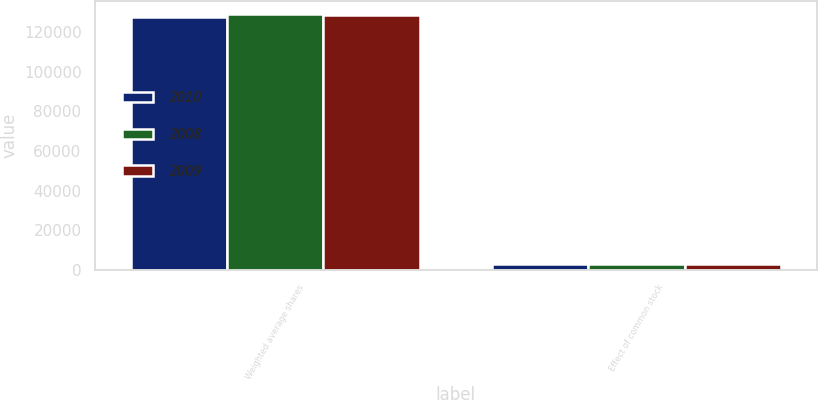Convert chart to OTSL. <chart><loc_0><loc_0><loc_500><loc_500><stacked_bar_chart><ecel><fcel>Weighted average shares<fcel>Effect of common stock<nl><fcel>2010<fcel>127767<fcel>3055<nl><fcel>2008<fcel>129462<fcel>2786<nl><fcel>2009<fcel>128533<fcel>3117<nl></chart> 